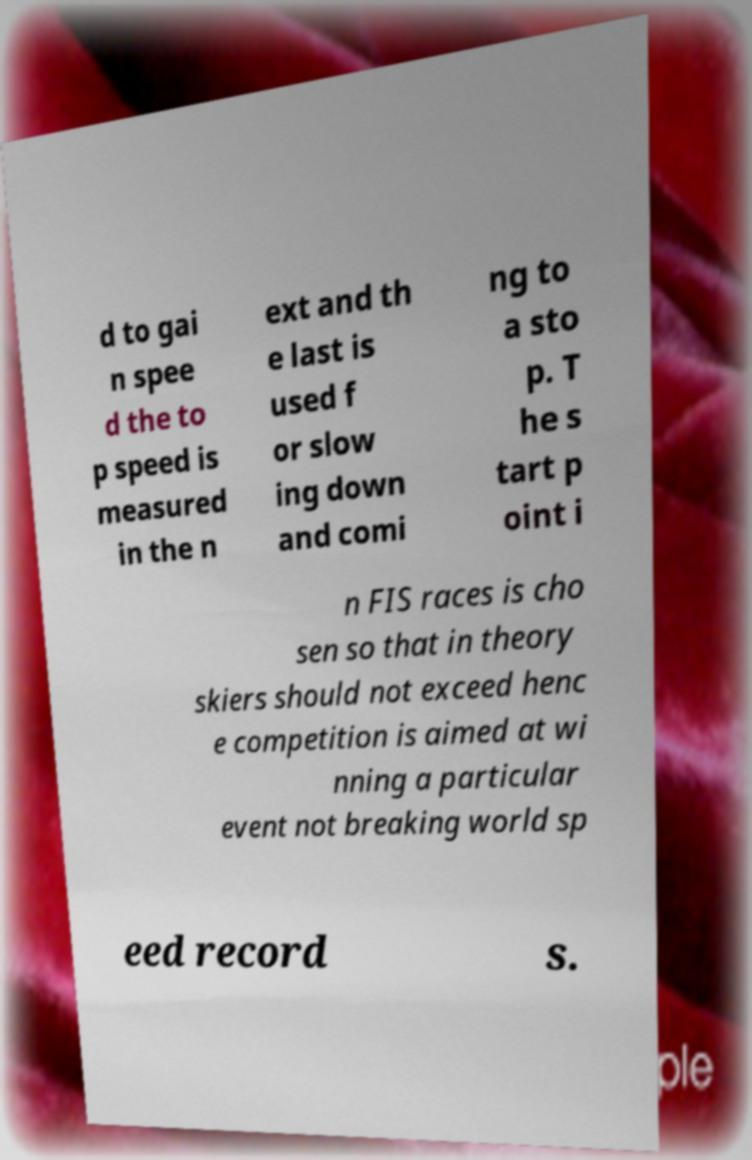For documentation purposes, I need the text within this image transcribed. Could you provide that? d to gai n spee d the to p speed is measured in the n ext and th e last is used f or slow ing down and comi ng to a sto p. T he s tart p oint i n FIS races is cho sen so that in theory skiers should not exceed henc e competition is aimed at wi nning a particular event not breaking world sp eed record s. 